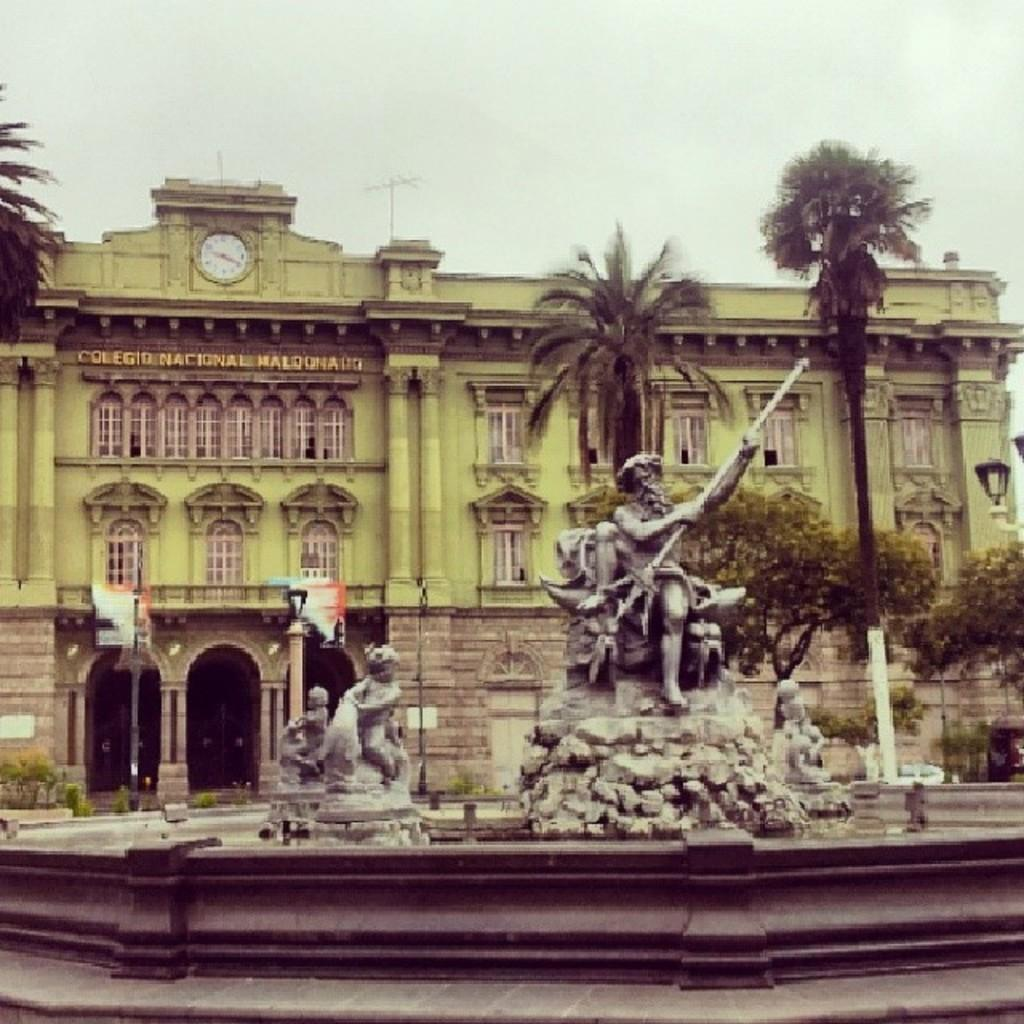What can be seen in the image that represents human-made art? There are statues in the image. What type of natural elements can be seen in the background of the image? There are trees in the background of the image. What type of structure can be seen in the background of the image? There is a building in the background of the image. What type of ornament is hanging from the kettle in the image? There is no kettle present in the image, so it is not possible to answer that question. 